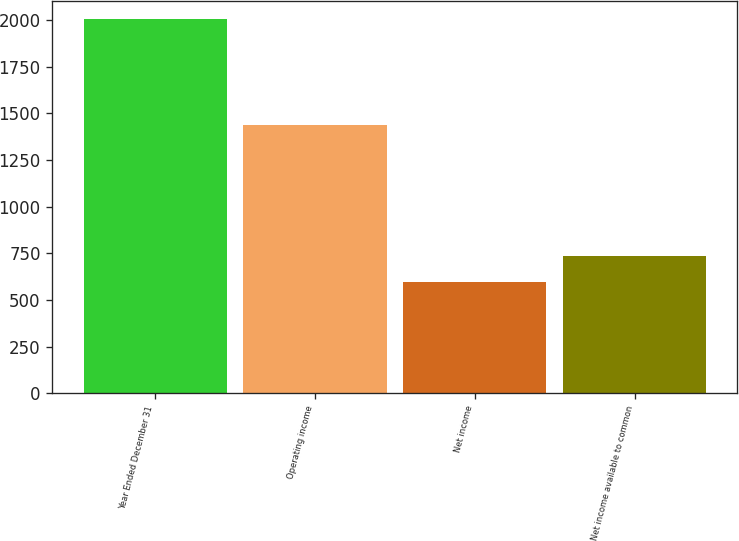Convert chart to OTSL. <chart><loc_0><loc_0><loc_500><loc_500><bar_chart><fcel>Year Ended December 31<fcel>Operating income<fcel>Net income<fcel>Net income available to common<nl><fcel>2004<fcel>1436<fcel>596<fcel>736.8<nl></chart> 